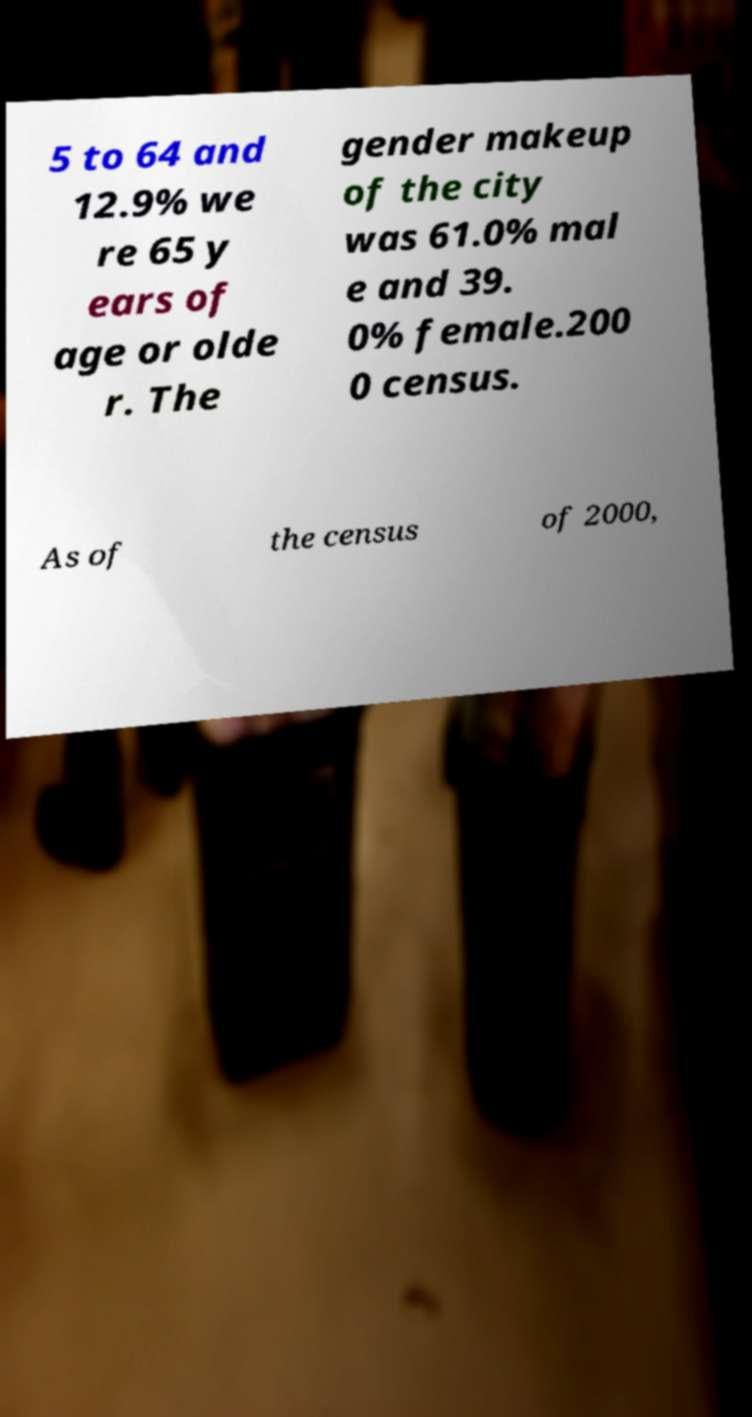I need the written content from this picture converted into text. Can you do that? 5 to 64 and 12.9% we re 65 y ears of age or olde r. The gender makeup of the city was 61.0% mal e and 39. 0% female.200 0 census. As of the census of 2000, 